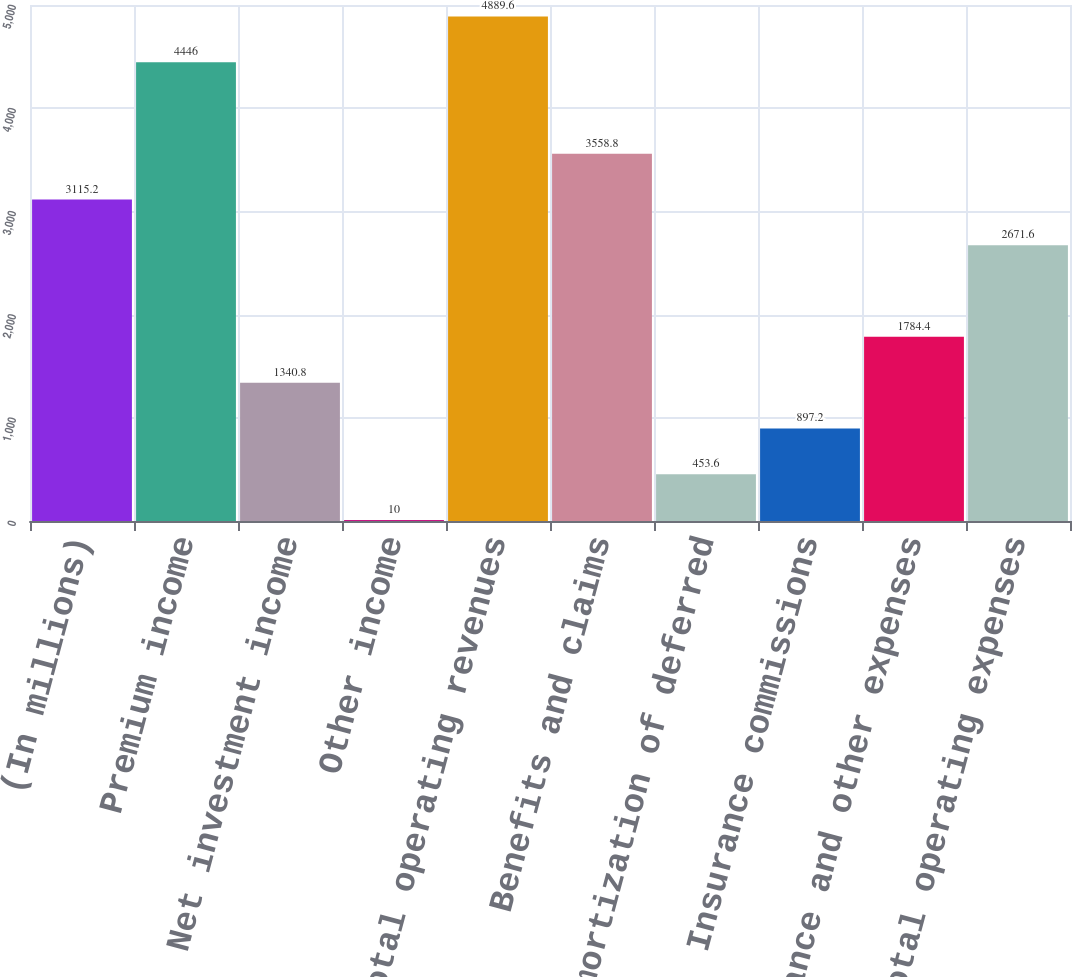Convert chart. <chart><loc_0><loc_0><loc_500><loc_500><bar_chart><fcel>(In millions)<fcel>Premium income<fcel>Net investment income<fcel>Other income<fcel>Total operating revenues<fcel>Benefits and claims<fcel>Amortization of deferred<fcel>Insurance commissions<fcel>Insurance and other expenses<fcel>Total operating expenses<nl><fcel>3115.2<fcel>4446<fcel>1340.8<fcel>10<fcel>4889.6<fcel>3558.8<fcel>453.6<fcel>897.2<fcel>1784.4<fcel>2671.6<nl></chart> 